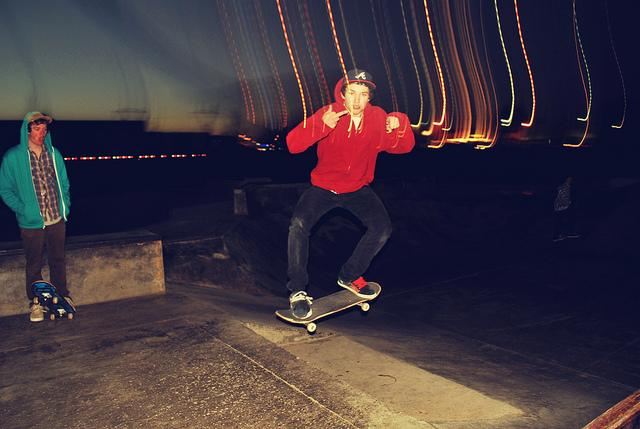The boy skateboarding is a fan of what baseball team?

Choices:
A) atlanta braves
B) montreal expos
C) detroit tigers
D) edmonton oilers atlanta braves 